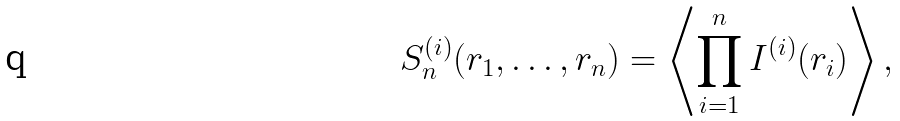Convert formula to latex. <formula><loc_0><loc_0><loc_500><loc_500>S _ { n } ^ { ( i ) } ( r _ { 1 } , \dots , r _ { n } ) = \left \langle \prod _ { i = 1 } ^ { n } I ^ { ( i ) } ( r _ { i } ) \right \rangle ,</formula> 